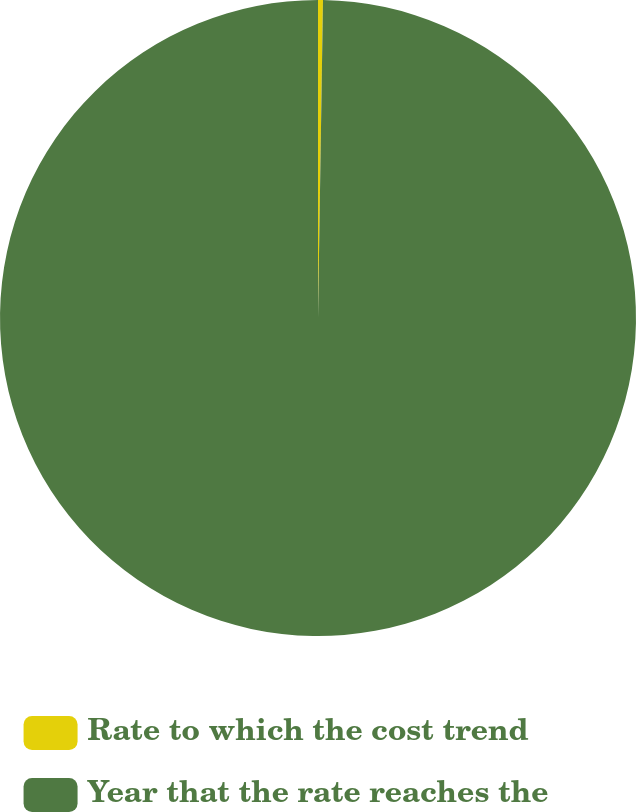Convert chart to OTSL. <chart><loc_0><loc_0><loc_500><loc_500><pie_chart><fcel>Rate to which the cost trend<fcel>Year that the rate reaches the<nl><fcel>0.25%<fcel>99.75%<nl></chart> 